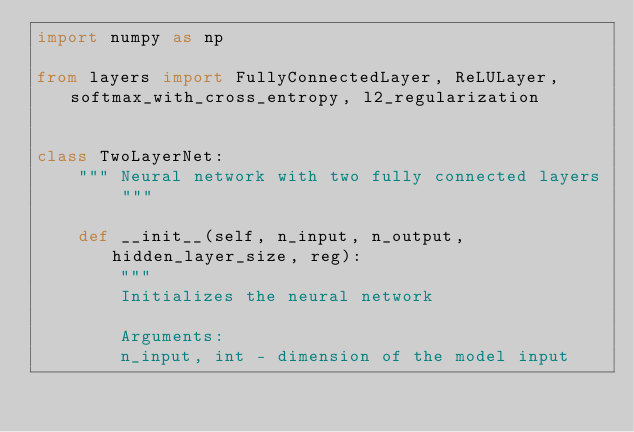Convert code to text. <code><loc_0><loc_0><loc_500><loc_500><_Python_>import numpy as np

from layers import FullyConnectedLayer, ReLULayer, softmax_with_cross_entropy, l2_regularization


class TwoLayerNet:
    """ Neural network with two fully connected layers """

    def __init__(self, n_input, n_output, hidden_layer_size, reg):
        """
        Initializes the neural network

        Arguments:
        n_input, int - dimension of the model input</code> 